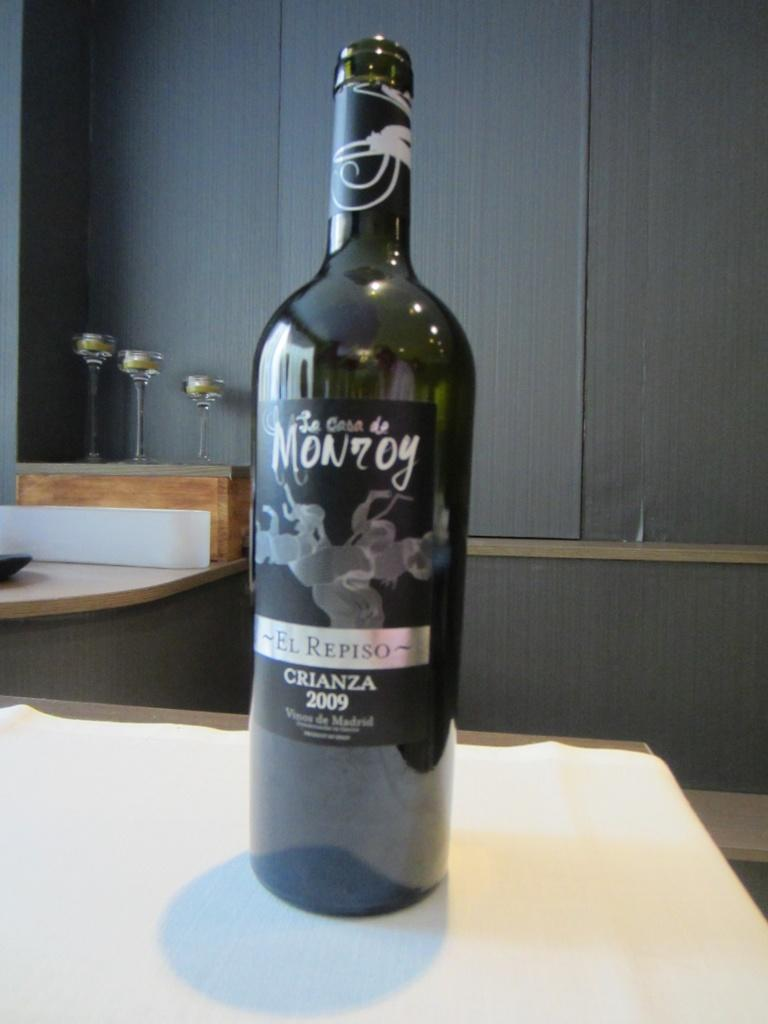<image>
Give a short and clear explanation of the subsequent image. A dark bottle of El Repiso Crianza from La Casa de Monroy. 